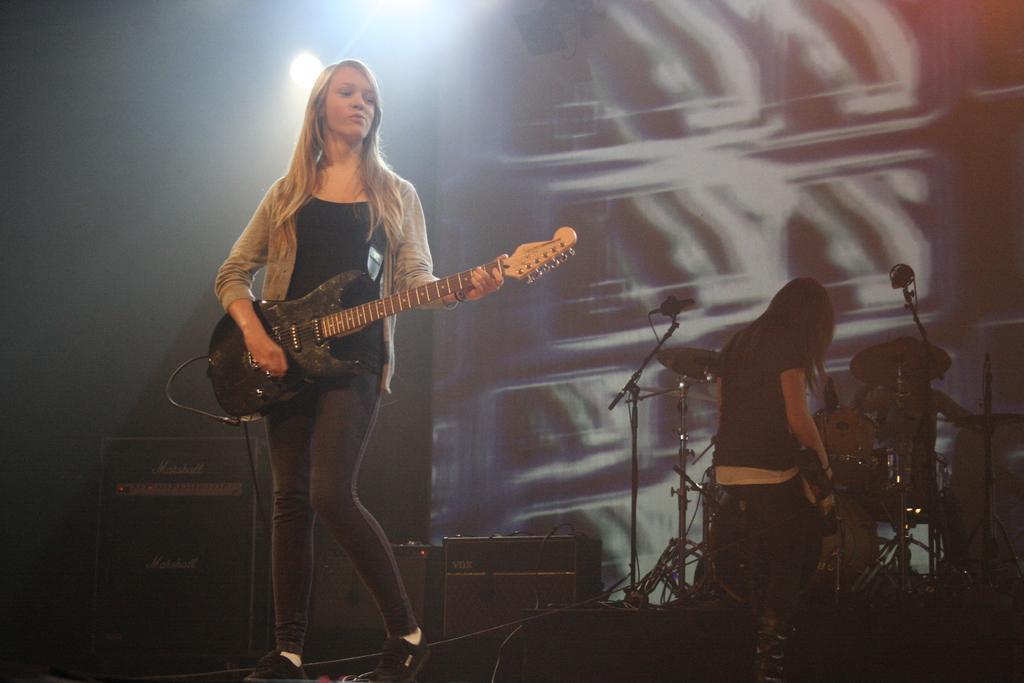Could you give a brief overview of what you see in this image? This picture shows a woman standing and playing a guitar and we sea other woman seated and holding a guitar in her hand and we see drums and couple of microphones 